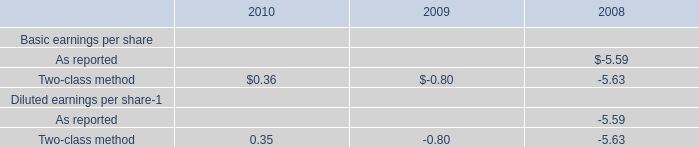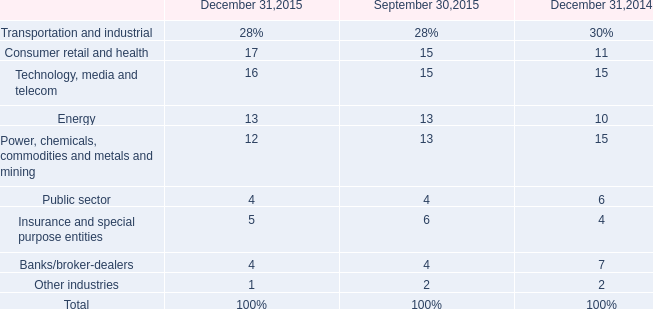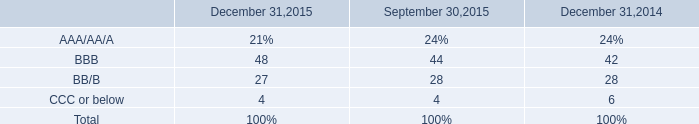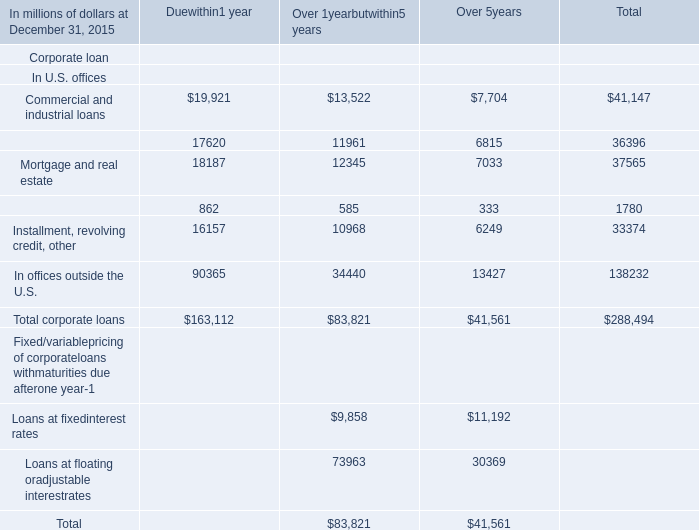What's the sum of all Duewithin1 year that are positive in 2015 for Corporate loan In U.S. offices? (in million) 
Computations: (((((19921 + 17620) + 18187) + 862) + 16157) + 90365)
Answer: 163112.0. 